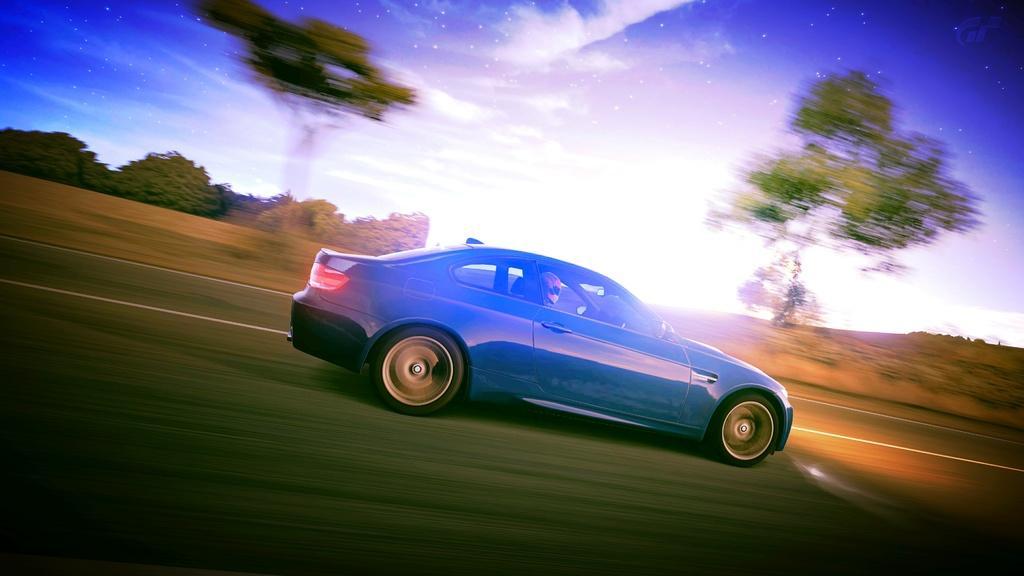What color is the car in the image? The car in the image is blue. Where is the car located in the image? The car is on the road. Is there anyone inside the car? Yes, there is a person in the car. What can be seen in the background of the image? There are trees and the sky visible in the background of the image. What type of metal is the car made of in the image? The facts provided do not mention the type of metal the car is made of, so we cannot determine that information from the image. 